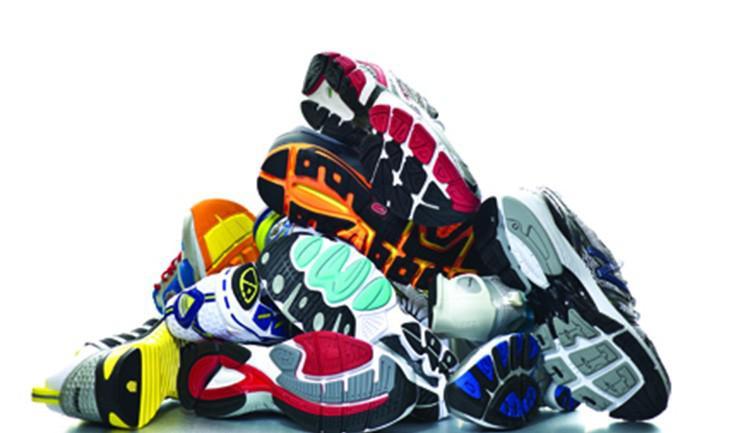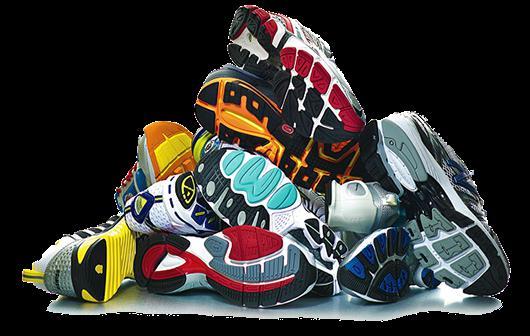The first image is the image on the left, the second image is the image on the right. Examine the images to the left and right. Is the description "There are piles of athletic shoes sitting on the floor in the center of the images." accurate? Answer yes or no. Yes. The first image is the image on the left, the second image is the image on the right. Assess this claim about the two images: "At least 30 shoes are piled up and none are in neat rows.". Correct or not? Answer yes or no. No. 